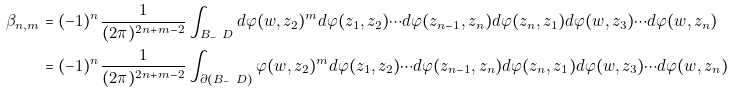Convert formula to latex. <formula><loc_0><loc_0><loc_500><loc_500>\beta _ { n , m } & = ( - 1 ) ^ { n } \frac { 1 } { ( 2 \pi ) ^ { 2 n + m - 2 } } \int _ { B _ { - } \ D } d \varphi ( w , z _ { 2 } ) ^ { m } d \varphi ( z _ { 1 } , z _ { 2 } ) \cdots d \varphi ( z _ { n - 1 } , z _ { n } ) d \varphi ( z _ { n } , z _ { 1 } ) d \varphi ( w , z _ { 3 } ) \cdots d \varphi ( w , z _ { n } ) \\ & = ( - 1 ) ^ { n } \frac { 1 } { ( 2 \pi ) ^ { 2 n + m - 2 } } \int _ { \partial ( B _ { - } \ D ) } \varphi ( w , z _ { 2 } ) ^ { m } d \varphi ( z _ { 1 } , z _ { 2 } ) \cdots d \varphi ( z _ { n - 1 } , z _ { n } ) d \varphi ( z _ { n } , z _ { 1 } ) d \varphi ( w , z _ { 3 } ) \cdots d \varphi ( w , z _ { n } )</formula> 